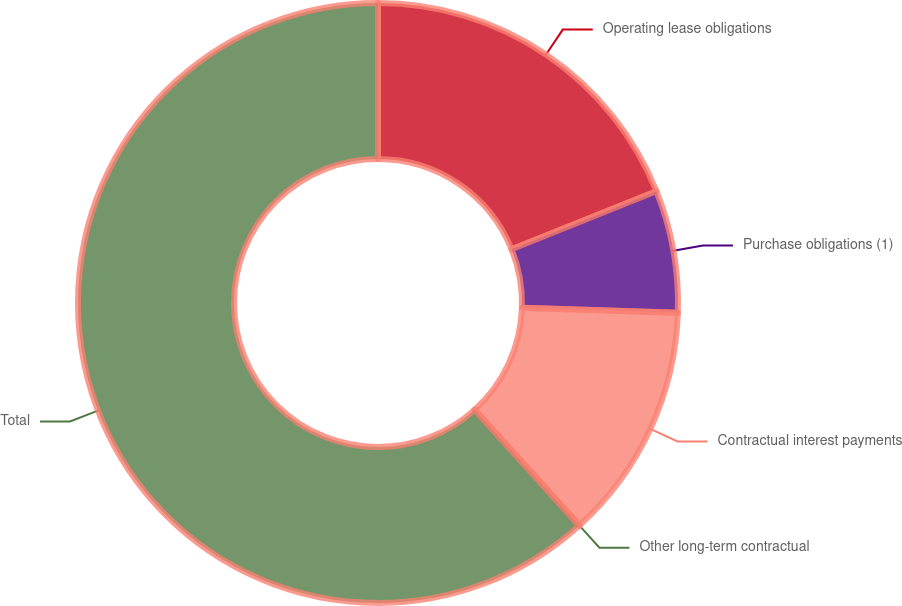Convert chart. <chart><loc_0><loc_0><loc_500><loc_500><pie_chart><fcel>Operating lease obligations<fcel>Purchase obligations (1)<fcel>Contractual interest payments<fcel>Other long-term contractual<fcel>Total<nl><fcel>18.92%<fcel>6.59%<fcel>12.76%<fcel>0.04%<fcel>61.68%<nl></chart> 